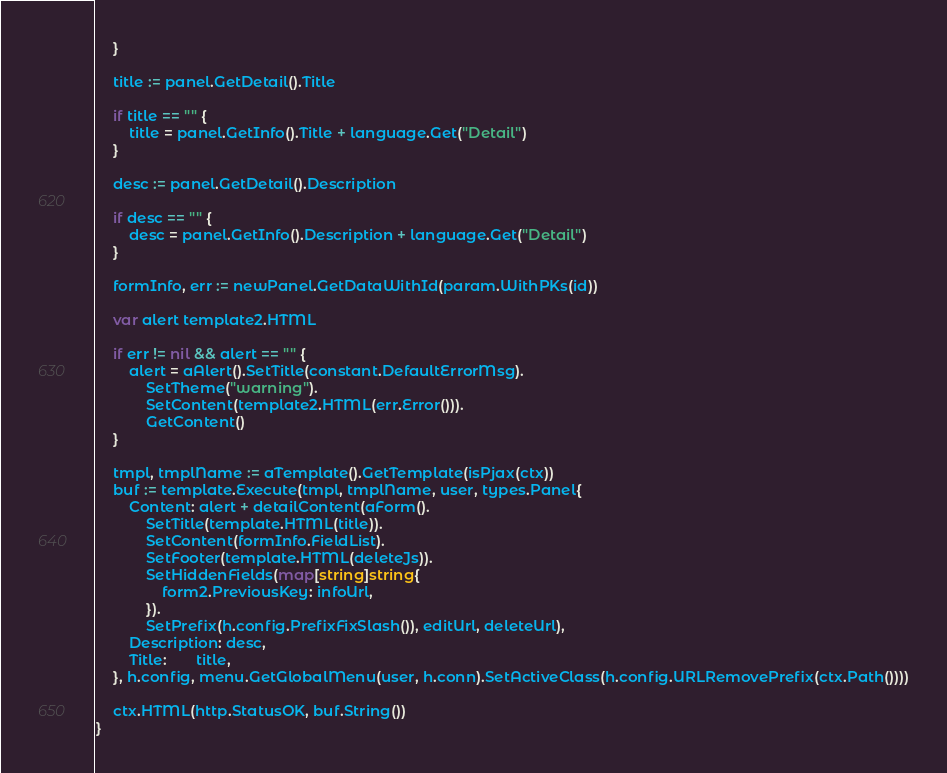<code> <loc_0><loc_0><loc_500><loc_500><_Go_>	}

	title := panel.GetDetail().Title

	if title == "" {
		title = panel.GetInfo().Title + language.Get("Detail")
	}

	desc := panel.GetDetail().Description

	if desc == "" {
		desc = panel.GetInfo().Description + language.Get("Detail")
	}

	formInfo, err := newPanel.GetDataWithId(param.WithPKs(id))

	var alert template2.HTML

	if err != nil && alert == "" {
		alert = aAlert().SetTitle(constant.DefaultErrorMsg).
			SetTheme("warning").
			SetContent(template2.HTML(err.Error())).
			GetContent()
	}

	tmpl, tmplName := aTemplate().GetTemplate(isPjax(ctx))
	buf := template.Execute(tmpl, tmplName, user, types.Panel{
		Content: alert + detailContent(aForm().
			SetTitle(template.HTML(title)).
			SetContent(formInfo.FieldList).
			SetFooter(template.HTML(deleteJs)).
			SetHiddenFields(map[string]string{
				form2.PreviousKey: infoUrl,
			}).
			SetPrefix(h.config.PrefixFixSlash()), editUrl, deleteUrl),
		Description: desc,
		Title:       title,
	}, h.config, menu.GetGlobalMenu(user, h.conn).SetActiveClass(h.config.URLRemovePrefix(ctx.Path())))

	ctx.HTML(http.StatusOK, buf.String())
}
</code> 